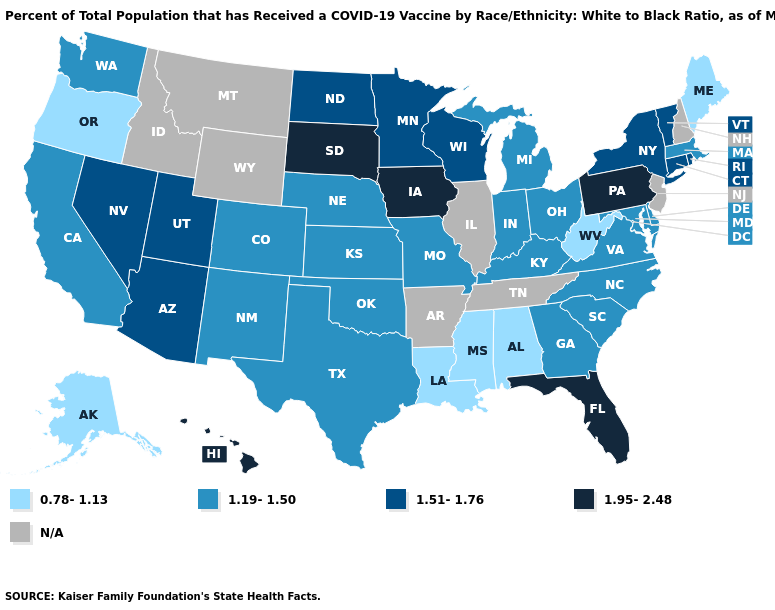What is the value of Georgia?
Keep it brief. 1.19-1.50. Does West Virginia have the highest value in the South?
Be succinct. No. What is the value of Louisiana?
Quick response, please. 0.78-1.13. What is the value of Hawaii?
Concise answer only. 1.95-2.48. What is the lowest value in states that border Louisiana?
Keep it brief. 0.78-1.13. What is the value of Vermont?
Write a very short answer. 1.51-1.76. What is the lowest value in the USA?
Answer briefly. 0.78-1.13. Name the states that have a value in the range 1.95-2.48?
Answer briefly. Florida, Hawaii, Iowa, Pennsylvania, South Dakota. What is the value of California?
Give a very brief answer. 1.19-1.50. Is the legend a continuous bar?
Write a very short answer. No. Does the first symbol in the legend represent the smallest category?
Short answer required. Yes. Which states have the lowest value in the Northeast?
Write a very short answer. Maine. Name the states that have a value in the range 1.19-1.50?
Concise answer only. California, Colorado, Delaware, Georgia, Indiana, Kansas, Kentucky, Maryland, Massachusetts, Michigan, Missouri, Nebraska, New Mexico, North Carolina, Ohio, Oklahoma, South Carolina, Texas, Virginia, Washington. Does Mississippi have the lowest value in the South?
Short answer required. Yes. How many symbols are there in the legend?
Be succinct. 5. 